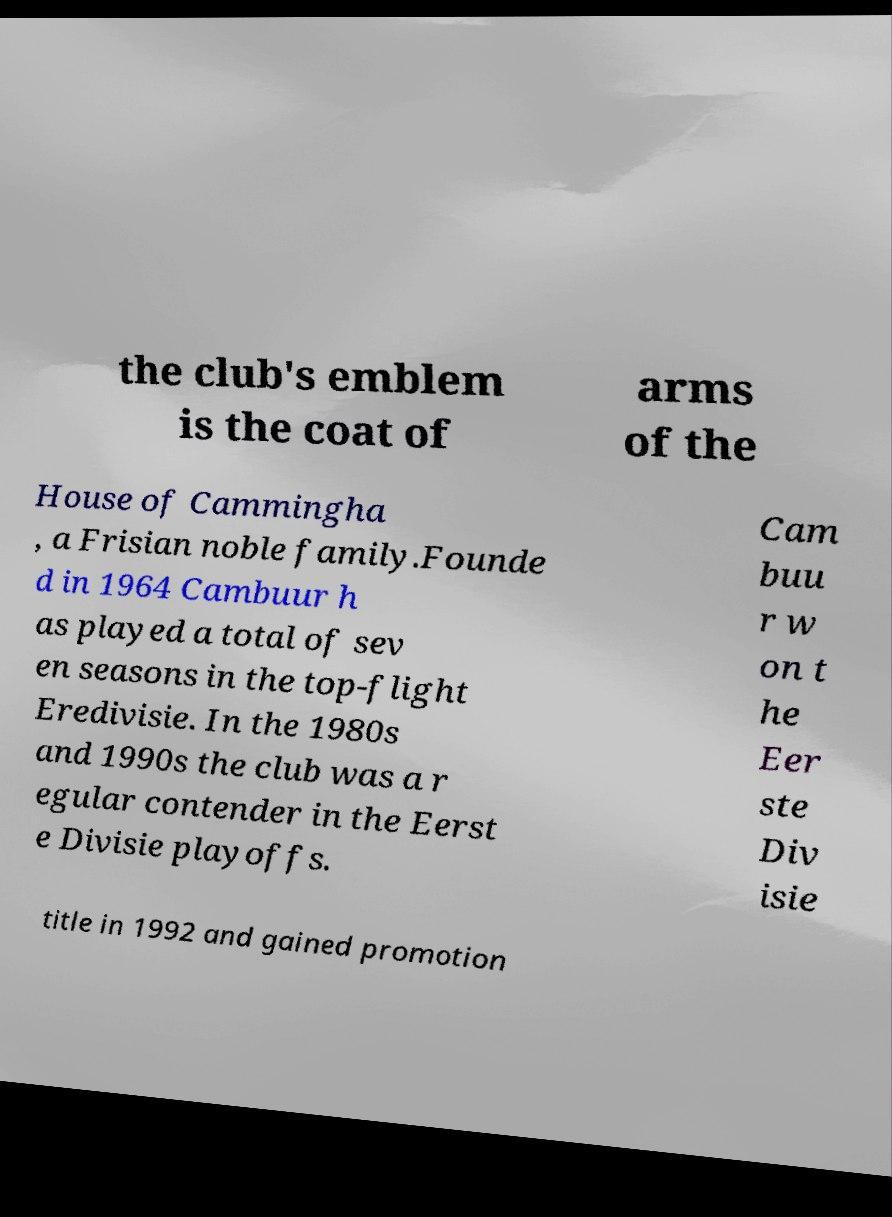I need the written content from this picture converted into text. Can you do that? the club's emblem is the coat of arms of the House of Cammingha , a Frisian noble family.Founde d in 1964 Cambuur h as played a total of sev en seasons in the top-flight Eredivisie. In the 1980s and 1990s the club was a r egular contender in the Eerst e Divisie playoffs. Cam buu r w on t he Eer ste Div isie title in 1992 and gained promotion 